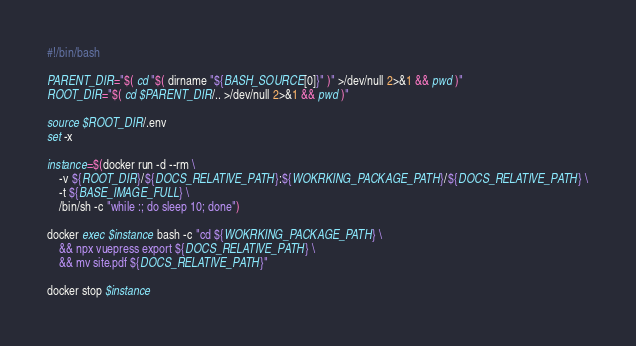Convert code to text. <code><loc_0><loc_0><loc_500><loc_500><_Bash_>#!/bin/bash

PARENT_DIR="$( cd "$( dirname "${BASH_SOURCE[0]}" )" >/dev/null 2>&1 && pwd )"
ROOT_DIR="$( cd $PARENT_DIR/.. >/dev/null 2>&1 && pwd )"

source $ROOT_DIR/.env
set -x

instance=$(docker run -d --rm \
    -v ${ROOT_DIR}/${DOCS_RELATIVE_PATH}:${WOKRKING_PACKAGE_PATH}/${DOCS_RELATIVE_PATH} \
    -t ${BASE_IMAGE_FULL} \
    /bin/sh -c "while :; do sleep 10; done")

docker exec $instance bash -c "cd ${WOKRKING_PACKAGE_PATH} \
    && npx vuepress export ${DOCS_RELATIVE_PATH} \
    && mv site.pdf ${DOCS_RELATIVE_PATH}"

docker stop $instance</code> 